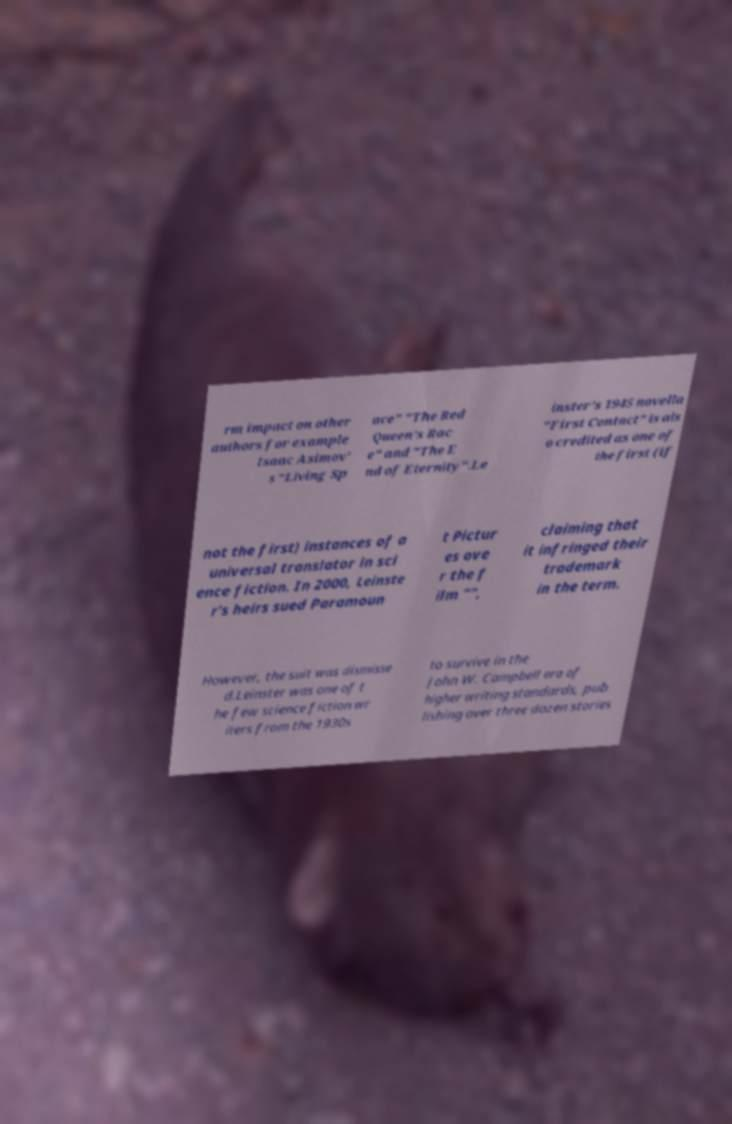Could you assist in decoding the text presented in this image and type it out clearly? rm impact on other authors for example Isaac Asimov' s "Living Sp ace" "The Red Queen's Rac e" and "The E nd of Eternity".Le inster's 1945 novella "First Contact" is als o credited as one of the first (if not the first) instances of a universal translator in sci ence fiction. In 2000, Leinste r's heirs sued Paramoun t Pictur es ove r the f ilm "", claiming that it infringed their trademark in the term. However, the suit was dismisse d.Leinster was one of t he few science fiction wr iters from the 1930s to survive in the John W. Campbell era of higher writing standards, pub lishing over three dozen stories 